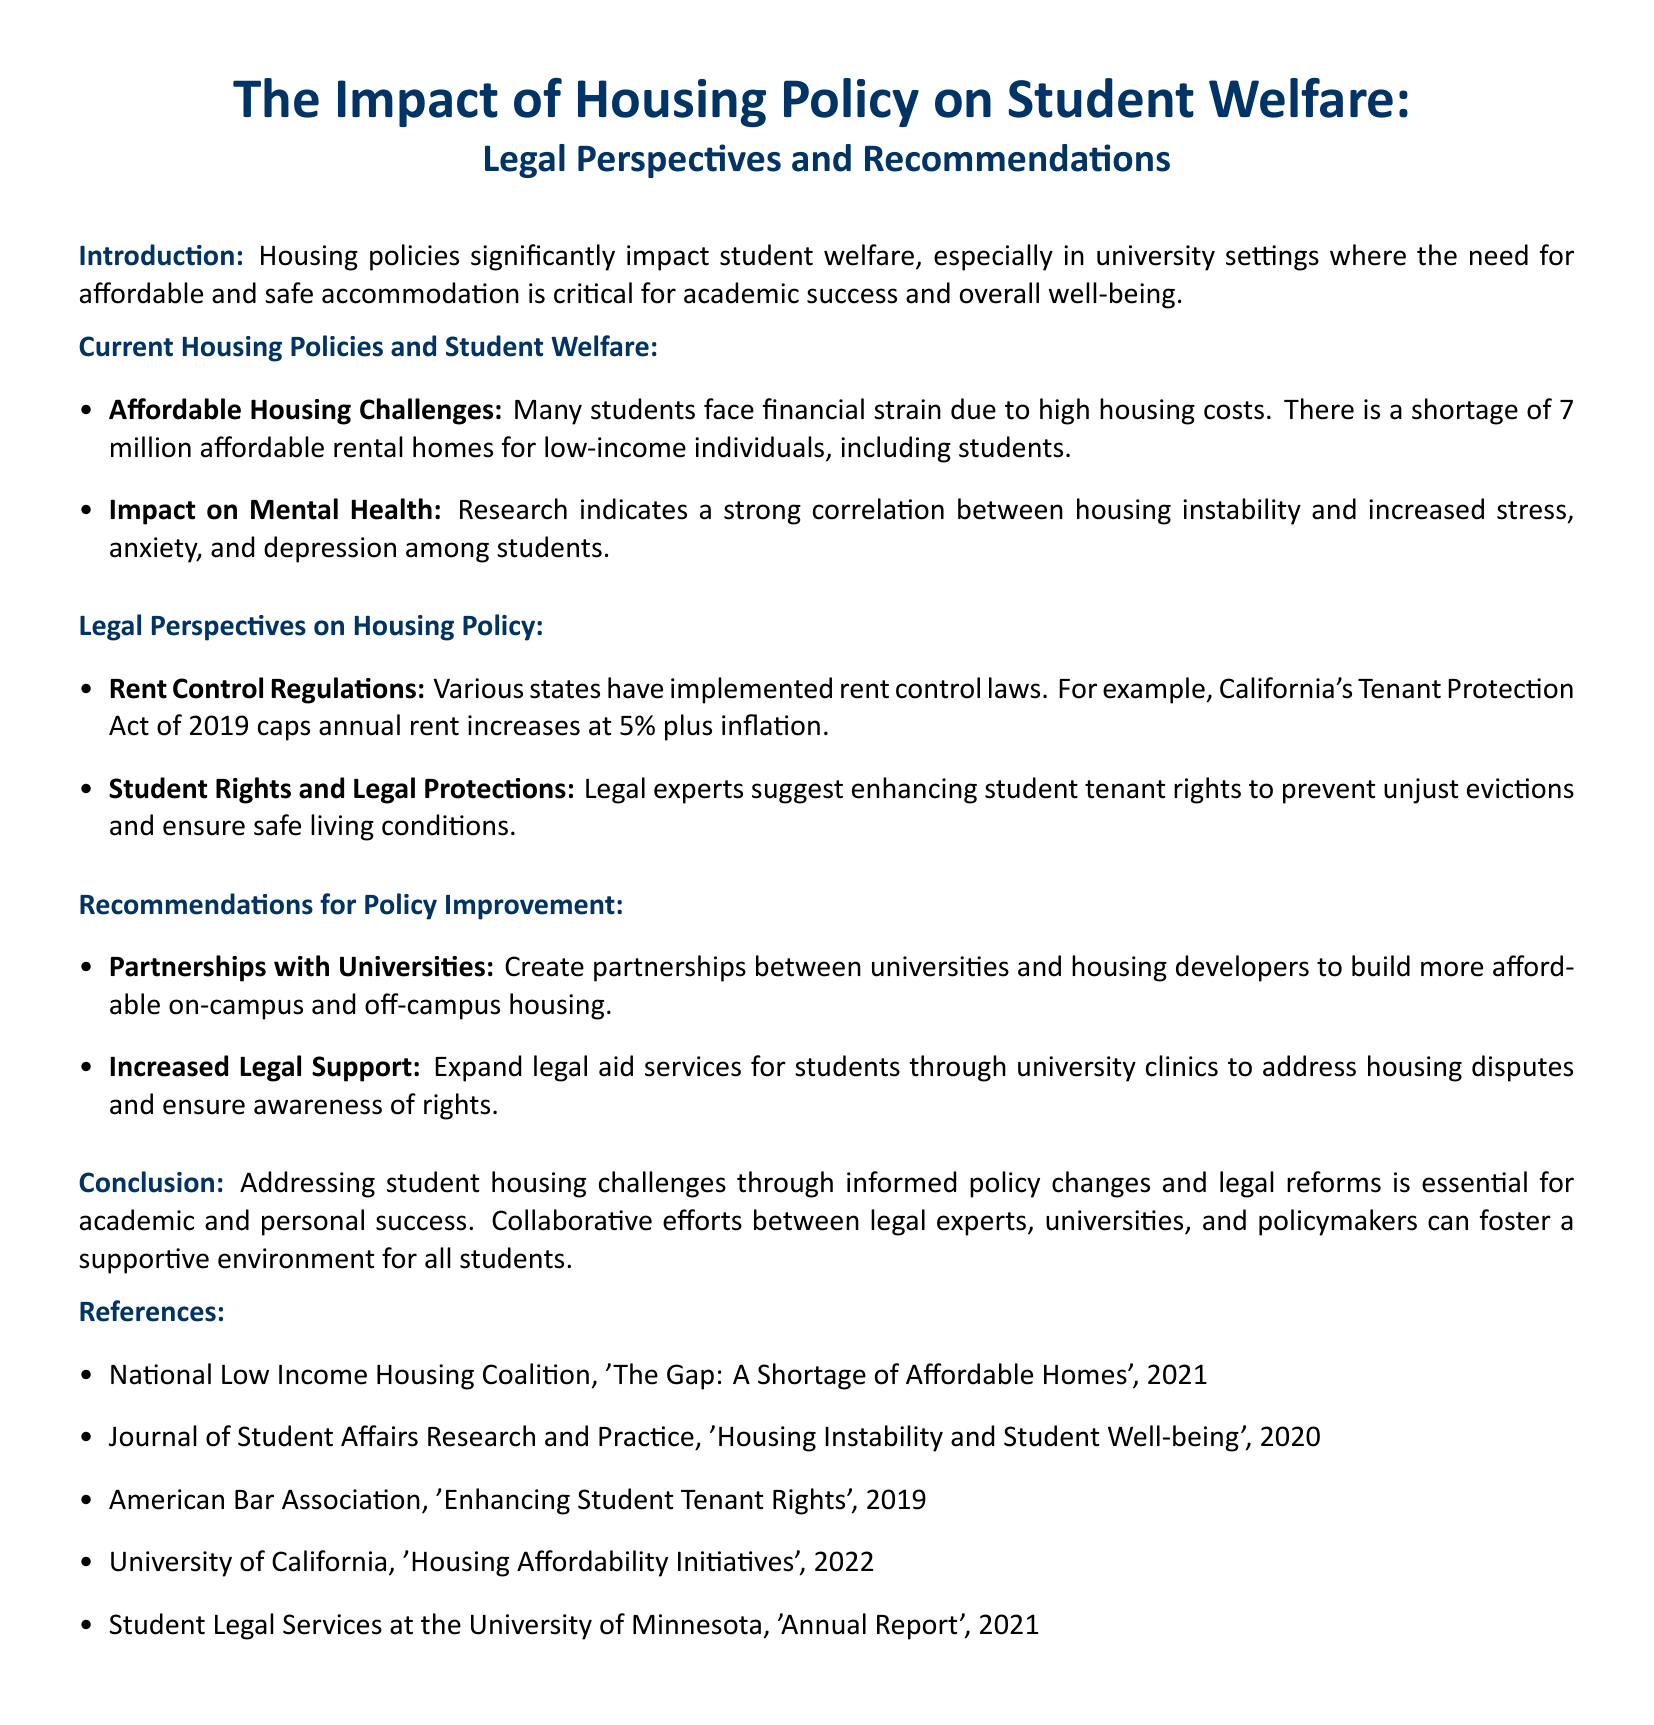What is the title of the document? The title of the document is presented in the header section, highlighting its focus on housing policy and student welfare.
Answer: The Impact of Housing Policy on Student Welfare: Legal Perspectives and Recommendations How many affordable rental homes are lacking for low-income individuals, including students? This figure is stated in the section discussing affordable housing challenges faced by students.
Answer: 7 million What year was California's Tenant Protection Act enacted? The document references a specific law, including its name and enactment year, in the legal perspectives section.
Answer: 2019 What is one suggested partnership for improving student housing? This is mentioned in the recommendations for policy improvement section, highlighting ways to foster affordable housing.
Answer: Partnerships with universities What correlation is mentioned regarding housing instability? The document states the mental health impact of housing instability, emphasizing the connection to various psychological issues.
Answer: Increased stress, anxiety, and depression What organization published a report on the shortage of affordable homes? The document cites references that address affordable housing issues, identifying a specific organization involved in this research.
Answer: National Low Income Housing Coalition What legal support is recommended for students? In the recommendations section, the document advocates for a specific type of assistance to help students address legal issues related to housing.
Answer: Expanded legal aid services What is a key conclusion of the document? The conclusion summarizes the essential action the document advocates for regarding student housing challenges.
Answer: Addressing student housing challenges through informed policy changes and legal reforms 